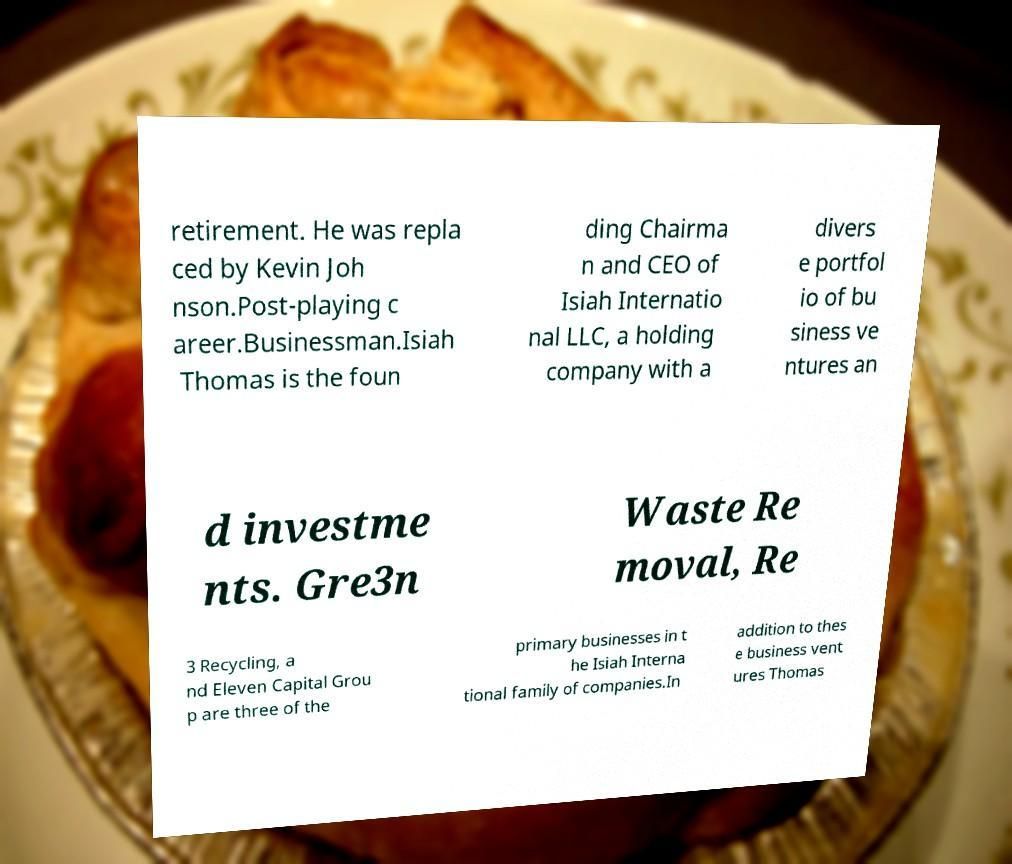Can you read and provide the text displayed in the image?This photo seems to have some interesting text. Can you extract and type it out for me? retirement. He was repla ced by Kevin Joh nson.Post-playing c areer.Businessman.Isiah Thomas is the foun ding Chairma n and CEO of Isiah Internatio nal LLC, a holding company with a divers e portfol io of bu siness ve ntures an d investme nts. Gre3n Waste Re moval, Re 3 Recycling, a nd Eleven Capital Grou p are three of the primary businesses in t he Isiah Interna tional family of companies.In addition to thes e business vent ures Thomas 